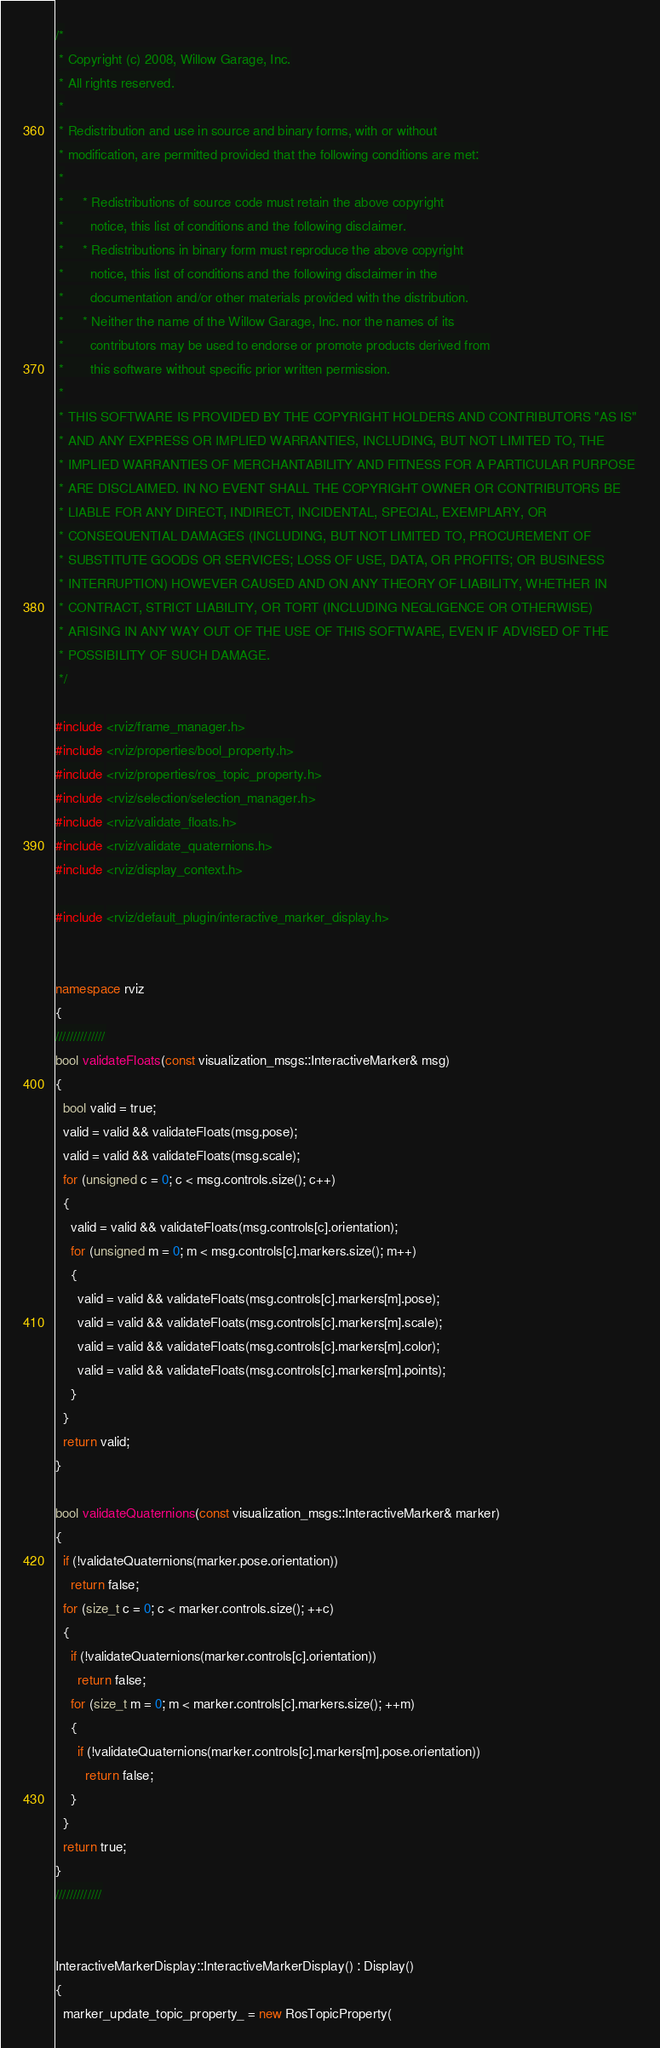<code> <loc_0><loc_0><loc_500><loc_500><_C++_>/*
 * Copyright (c) 2008, Willow Garage, Inc.
 * All rights reserved.
 *
 * Redistribution and use in source and binary forms, with or without
 * modification, are permitted provided that the following conditions are met:
 *
 *     * Redistributions of source code must retain the above copyright
 *       notice, this list of conditions and the following disclaimer.
 *     * Redistributions in binary form must reproduce the above copyright
 *       notice, this list of conditions and the following disclaimer in the
 *       documentation and/or other materials provided with the distribution.
 *     * Neither the name of the Willow Garage, Inc. nor the names of its
 *       contributors may be used to endorse or promote products derived from
 *       this software without specific prior written permission.
 *
 * THIS SOFTWARE IS PROVIDED BY THE COPYRIGHT HOLDERS AND CONTRIBUTORS "AS IS"
 * AND ANY EXPRESS OR IMPLIED WARRANTIES, INCLUDING, BUT NOT LIMITED TO, THE
 * IMPLIED WARRANTIES OF MERCHANTABILITY AND FITNESS FOR A PARTICULAR PURPOSE
 * ARE DISCLAIMED. IN NO EVENT SHALL THE COPYRIGHT OWNER OR CONTRIBUTORS BE
 * LIABLE FOR ANY DIRECT, INDIRECT, INCIDENTAL, SPECIAL, EXEMPLARY, OR
 * CONSEQUENTIAL DAMAGES (INCLUDING, BUT NOT LIMITED TO, PROCUREMENT OF
 * SUBSTITUTE GOODS OR SERVICES; LOSS OF USE, DATA, OR PROFITS; OR BUSINESS
 * INTERRUPTION) HOWEVER CAUSED AND ON ANY THEORY OF LIABILITY, WHETHER IN
 * CONTRACT, STRICT LIABILITY, OR TORT (INCLUDING NEGLIGENCE OR OTHERWISE)
 * ARISING IN ANY WAY OUT OF THE USE OF THIS SOFTWARE, EVEN IF ADVISED OF THE
 * POSSIBILITY OF SUCH DAMAGE.
 */

#include <rviz/frame_manager.h>
#include <rviz/properties/bool_property.h>
#include <rviz/properties/ros_topic_property.h>
#include <rviz/selection/selection_manager.h>
#include <rviz/validate_floats.h>
#include <rviz/validate_quaternions.h>
#include <rviz/display_context.h>

#include <rviz/default_plugin/interactive_marker_display.h>


namespace rviz
{
//////////////
bool validateFloats(const visualization_msgs::InteractiveMarker& msg)
{
  bool valid = true;
  valid = valid && validateFloats(msg.pose);
  valid = valid && validateFloats(msg.scale);
  for (unsigned c = 0; c < msg.controls.size(); c++)
  {
    valid = valid && validateFloats(msg.controls[c].orientation);
    for (unsigned m = 0; m < msg.controls[c].markers.size(); m++)
    {
      valid = valid && validateFloats(msg.controls[c].markers[m].pose);
      valid = valid && validateFloats(msg.controls[c].markers[m].scale);
      valid = valid && validateFloats(msg.controls[c].markers[m].color);
      valid = valid && validateFloats(msg.controls[c].markers[m].points);
    }
  }
  return valid;
}

bool validateQuaternions(const visualization_msgs::InteractiveMarker& marker)
{
  if (!validateQuaternions(marker.pose.orientation))
    return false;
  for (size_t c = 0; c < marker.controls.size(); ++c)
  {
    if (!validateQuaternions(marker.controls[c].orientation))
      return false;
    for (size_t m = 0; m < marker.controls[c].markers.size(); ++m)
    {
      if (!validateQuaternions(marker.controls[c].markers[m].pose.orientation))
        return false;
    }
  }
  return true;
}
/////////////


InteractiveMarkerDisplay::InteractiveMarkerDisplay() : Display()
{
  marker_update_topic_property_ = new RosTopicProperty(</code> 